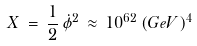Convert formula to latex. <formula><loc_0><loc_0><loc_500><loc_500>X \, = \, \frac { 1 } { 2 } \, \dot { \phi } ^ { 2 } \, \approx \, 1 0 ^ { 6 2 } \, ( G e V ) ^ { 4 }</formula> 